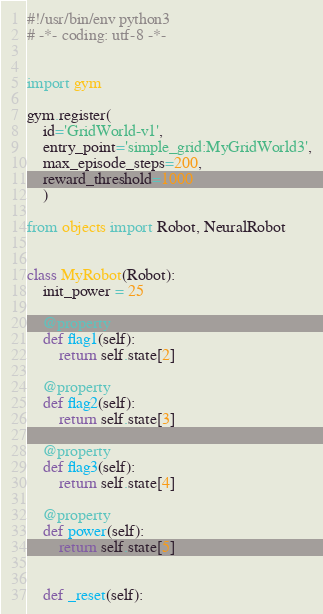<code> <loc_0><loc_0><loc_500><loc_500><_Python_>#!/usr/bin/env python3
# -*- coding: utf-8 -*-


import gym

gym.register(
    id='GridWorld-v1',
    entry_point='simple_grid:MyGridWorld3',
    max_episode_steps=200,
    reward_threshold=1000
    )

from objects import Robot, NeuralRobot


class MyRobot(Robot):
    init_power = 25

    @property
    def flag1(self):
        return self.state[2]

    @property
    def flag2(self):
        return self.state[3]

    @property
    def flag3(self):
        return self.state[4]

    @property
    def power(self):
        return self.state[5]
    

    def _reset(self):</code> 